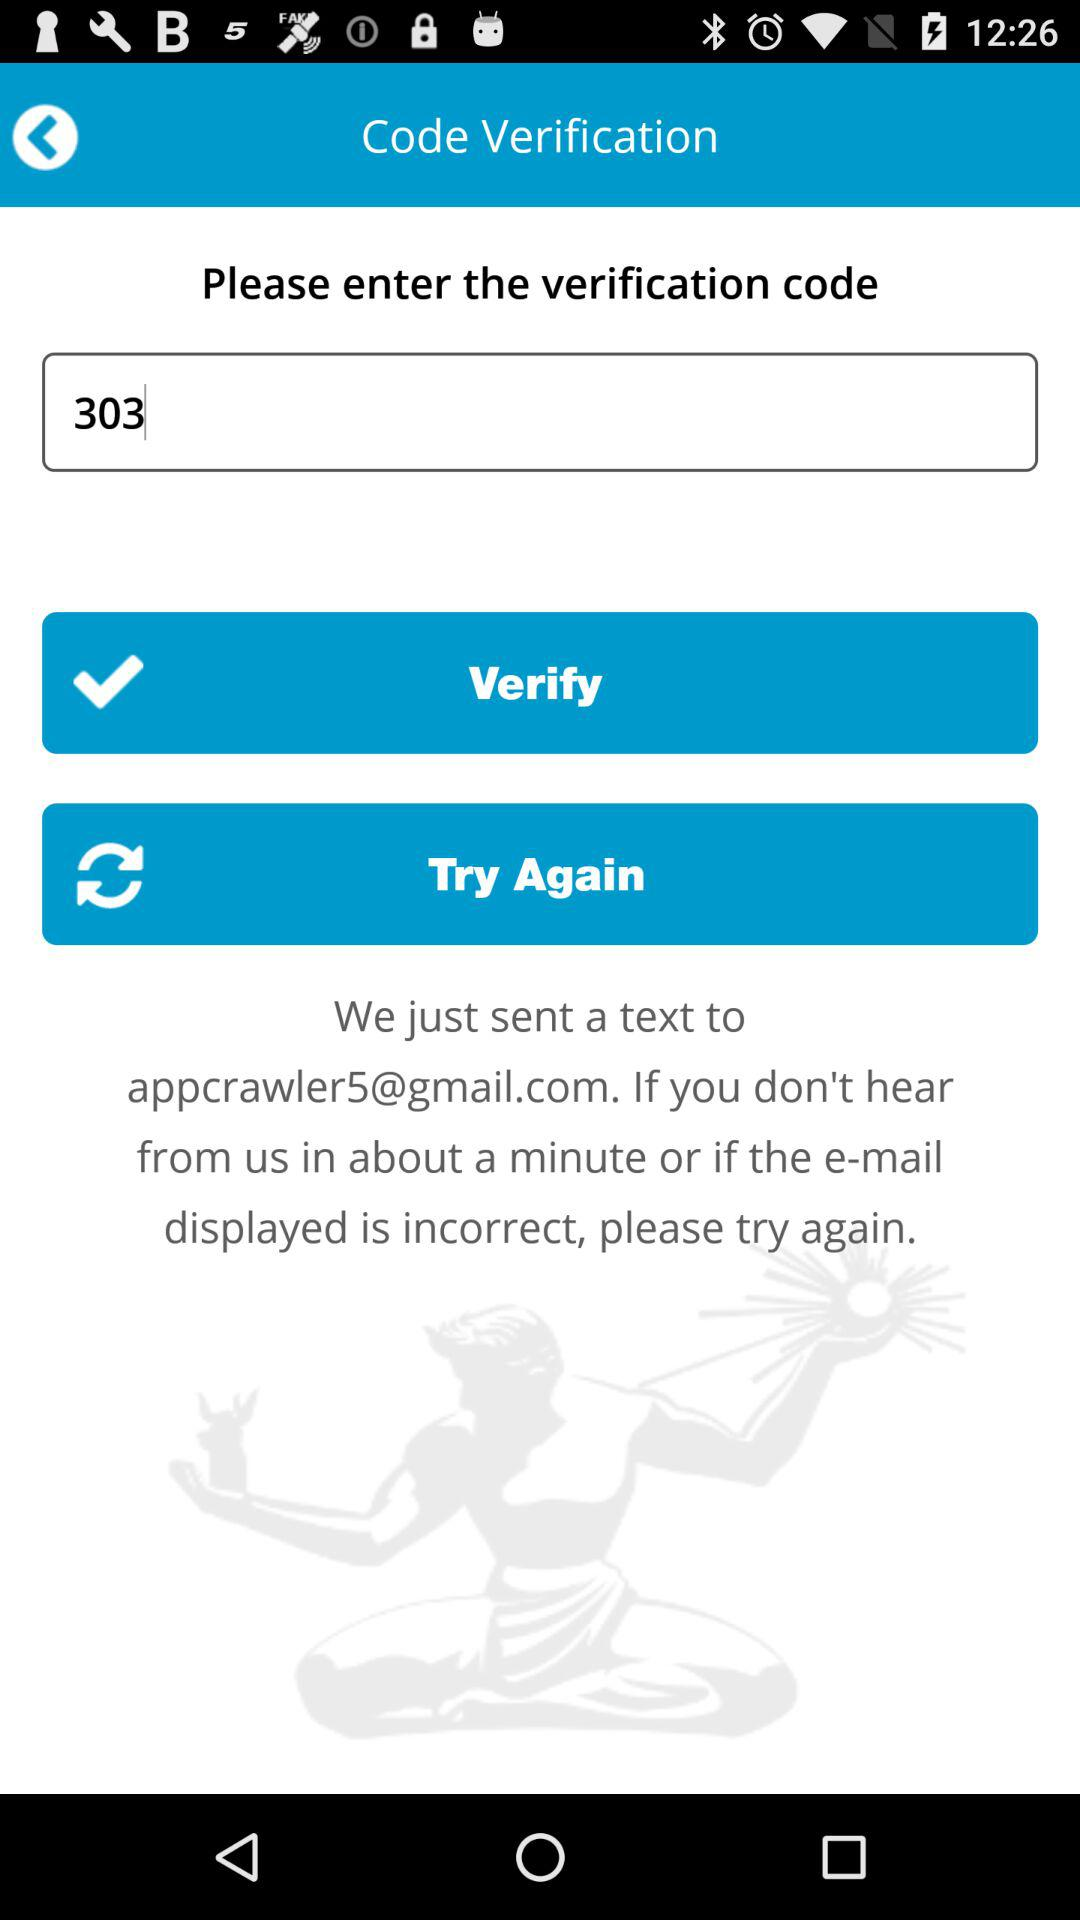What is the verification code? The verification code is 303. 